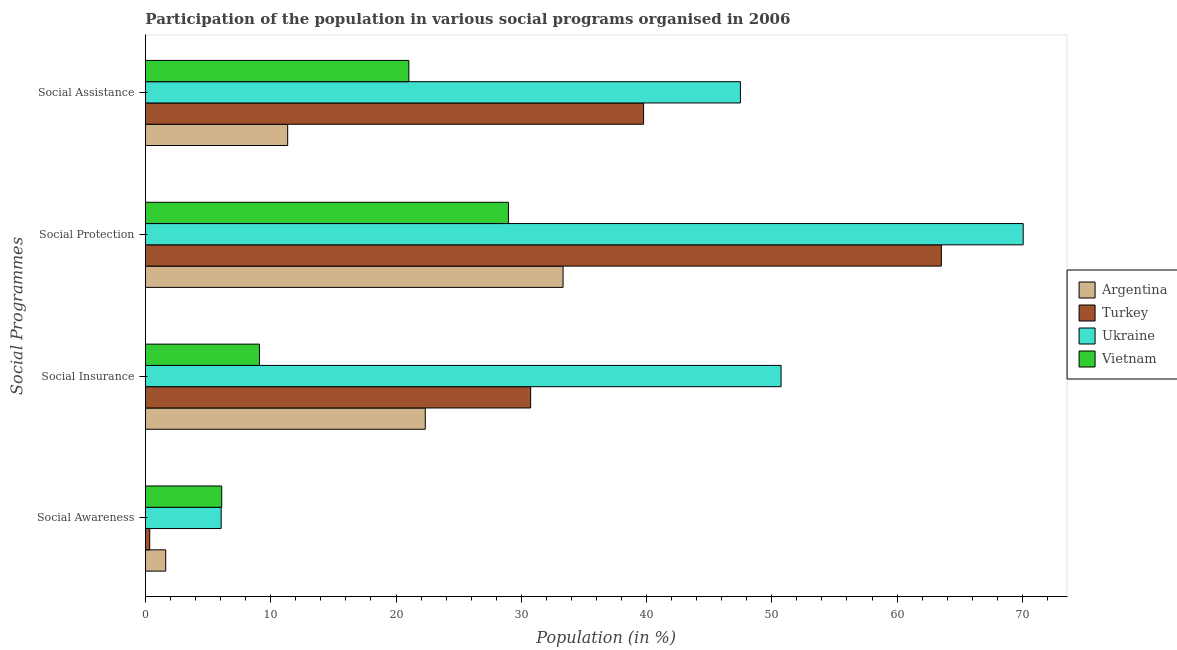How many different coloured bars are there?
Offer a very short reply. 4. How many groups of bars are there?
Ensure brevity in your answer.  4. Are the number of bars per tick equal to the number of legend labels?
Your response must be concise. Yes. How many bars are there on the 1st tick from the top?
Provide a short and direct response. 4. What is the label of the 3rd group of bars from the top?
Ensure brevity in your answer.  Social Insurance. What is the participation of population in social assistance programs in Ukraine?
Keep it short and to the point. 47.5. Across all countries, what is the maximum participation of population in social assistance programs?
Offer a very short reply. 47.5. Across all countries, what is the minimum participation of population in social assistance programs?
Make the answer very short. 11.35. In which country was the participation of population in social protection programs maximum?
Give a very brief answer. Ukraine. What is the total participation of population in social protection programs in the graph?
Your answer should be compact. 195.91. What is the difference between the participation of population in social protection programs in Ukraine and that in Vietnam?
Provide a short and direct response. 41.09. What is the difference between the participation of population in social assistance programs in Argentina and the participation of population in social awareness programs in Ukraine?
Your response must be concise. 5.31. What is the average participation of population in social awareness programs per country?
Provide a succinct answer. 3.52. What is the difference between the participation of population in social protection programs and participation of population in social insurance programs in Vietnam?
Your answer should be very brief. 19.88. In how many countries, is the participation of population in social awareness programs greater than 56 %?
Give a very brief answer. 0. What is the ratio of the participation of population in social assistance programs in Ukraine to that in Vietnam?
Make the answer very short. 2.26. Is the difference between the participation of population in social protection programs in Turkey and Argentina greater than the difference between the participation of population in social awareness programs in Turkey and Argentina?
Offer a terse response. Yes. What is the difference between the highest and the second highest participation of population in social insurance programs?
Your answer should be very brief. 19.99. What is the difference between the highest and the lowest participation of population in social protection programs?
Your response must be concise. 41.09. In how many countries, is the participation of population in social assistance programs greater than the average participation of population in social assistance programs taken over all countries?
Your answer should be compact. 2. Is the sum of the participation of population in social assistance programs in Turkey and Argentina greater than the maximum participation of population in social insurance programs across all countries?
Offer a terse response. Yes. What does the 2nd bar from the top in Social Protection represents?
Your answer should be very brief. Ukraine. What does the 3rd bar from the bottom in Social Insurance represents?
Your answer should be compact. Ukraine. Is it the case that in every country, the sum of the participation of population in social awareness programs and participation of population in social insurance programs is greater than the participation of population in social protection programs?
Give a very brief answer. No. How many bars are there?
Offer a terse response. 16. What is the difference between two consecutive major ticks on the X-axis?
Provide a succinct answer. 10. Does the graph contain any zero values?
Keep it short and to the point. No. Does the graph contain grids?
Offer a terse response. No. Where does the legend appear in the graph?
Give a very brief answer. Center right. How are the legend labels stacked?
Give a very brief answer. Vertical. What is the title of the graph?
Provide a short and direct response. Participation of the population in various social programs organised in 2006. Does "Antigua and Barbuda" appear as one of the legend labels in the graph?
Keep it short and to the point. No. What is the label or title of the X-axis?
Give a very brief answer. Population (in %). What is the label or title of the Y-axis?
Your answer should be compact. Social Programmes. What is the Population (in %) of Argentina in Social Awareness?
Your response must be concise. 1.62. What is the Population (in %) of Turkey in Social Awareness?
Provide a succinct answer. 0.34. What is the Population (in %) of Ukraine in Social Awareness?
Your answer should be very brief. 6.04. What is the Population (in %) in Vietnam in Social Awareness?
Your response must be concise. 6.09. What is the Population (in %) in Argentina in Social Insurance?
Your answer should be very brief. 22.34. What is the Population (in %) in Turkey in Social Insurance?
Provide a succinct answer. 30.75. What is the Population (in %) in Ukraine in Social Insurance?
Make the answer very short. 50.74. What is the Population (in %) in Vietnam in Social Insurance?
Offer a very short reply. 9.1. What is the Population (in %) of Argentina in Social Protection?
Provide a short and direct response. 33.34. What is the Population (in %) of Turkey in Social Protection?
Keep it short and to the point. 63.53. What is the Population (in %) of Ukraine in Social Protection?
Provide a succinct answer. 70.07. What is the Population (in %) of Vietnam in Social Protection?
Provide a succinct answer. 28.98. What is the Population (in %) in Argentina in Social Assistance?
Ensure brevity in your answer.  11.35. What is the Population (in %) of Turkey in Social Assistance?
Your response must be concise. 39.76. What is the Population (in %) of Ukraine in Social Assistance?
Keep it short and to the point. 47.5. What is the Population (in %) in Vietnam in Social Assistance?
Give a very brief answer. 21.03. Across all Social Programmes, what is the maximum Population (in %) of Argentina?
Keep it short and to the point. 33.34. Across all Social Programmes, what is the maximum Population (in %) of Turkey?
Offer a very short reply. 63.53. Across all Social Programmes, what is the maximum Population (in %) in Ukraine?
Make the answer very short. 70.07. Across all Social Programmes, what is the maximum Population (in %) of Vietnam?
Keep it short and to the point. 28.98. Across all Social Programmes, what is the minimum Population (in %) in Argentina?
Your answer should be very brief. 1.62. Across all Social Programmes, what is the minimum Population (in %) in Turkey?
Offer a terse response. 0.34. Across all Social Programmes, what is the minimum Population (in %) of Ukraine?
Ensure brevity in your answer.  6.04. Across all Social Programmes, what is the minimum Population (in %) of Vietnam?
Offer a very short reply. 6.09. What is the total Population (in %) of Argentina in the graph?
Your answer should be very brief. 68.64. What is the total Population (in %) of Turkey in the graph?
Give a very brief answer. 134.39. What is the total Population (in %) in Ukraine in the graph?
Offer a very short reply. 174.35. What is the total Population (in %) in Vietnam in the graph?
Your answer should be very brief. 65.19. What is the difference between the Population (in %) of Argentina in Social Awareness and that in Social Insurance?
Ensure brevity in your answer.  -20.72. What is the difference between the Population (in %) in Turkey in Social Awareness and that in Social Insurance?
Ensure brevity in your answer.  -30.41. What is the difference between the Population (in %) in Ukraine in Social Awareness and that in Social Insurance?
Provide a short and direct response. -44.7. What is the difference between the Population (in %) of Vietnam in Social Awareness and that in Social Insurance?
Keep it short and to the point. -3.01. What is the difference between the Population (in %) of Argentina in Social Awareness and that in Social Protection?
Provide a short and direct response. -31.72. What is the difference between the Population (in %) of Turkey in Social Awareness and that in Social Protection?
Your answer should be very brief. -63.19. What is the difference between the Population (in %) in Ukraine in Social Awareness and that in Social Protection?
Keep it short and to the point. -64.02. What is the difference between the Population (in %) in Vietnam in Social Awareness and that in Social Protection?
Ensure brevity in your answer.  -22.89. What is the difference between the Population (in %) in Argentina in Social Awareness and that in Social Assistance?
Your answer should be very brief. -9.74. What is the difference between the Population (in %) of Turkey in Social Awareness and that in Social Assistance?
Provide a short and direct response. -39.42. What is the difference between the Population (in %) of Ukraine in Social Awareness and that in Social Assistance?
Ensure brevity in your answer.  -41.45. What is the difference between the Population (in %) in Vietnam in Social Awareness and that in Social Assistance?
Provide a short and direct response. -14.94. What is the difference between the Population (in %) of Argentina in Social Insurance and that in Social Protection?
Your answer should be very brief. -11. What is the difference between the Population (in %) of Turkey in Social Insurance and that in Social Protection?
Your answer should be compact. -32.78. What is the difference between the Population (in %) of Ukraine in Social Insurance and that in Social Protection?
Your answer should be very brief. -19.33. What is the difference between the Population (in %) of Vietnam in Social Insurance and that in Social Protection?
Your answer should be compact. -19.88. What is the difference between the Population (in %) of Argentina in Social Insurance and that in Social Assistance?
Provide a succinct answer. 10.98. What is the difference between the Population (in %) of Turkey in Social Insurance and that in Social Assistance?
Your response must be concise. -9.01. What is the difference between the Population (in %) of Ukraine in Social Insurance and that in Social Assistance?
Your answer should be compact. 3.24. What is the difference between the Population (in %) in Vietnam in Social Insurance and that in Social Assistance?
Provide a succinct answer. -11.93. What is the difference between the Population (in %) in Argentina in Social Protection and that in Social Assistance?
Your answer should be very brief. 21.98. What is the difference between the Population (in %) of Turkey in Social Protection and that in Social Assistance?
Offer a terse response. 23.77. What is the difference between the Population (in %) in Ukraine in Social Protection and that in Social Assistance?
Your answer should be very brief. 22.57. What is the difference between the Population (in %) of Vietnam in Social Protection and that in Social Assistance?
Offer a very short reply. 7.95. What is the difference between the Population (in %) of Argentina in Social Awareness and the Population (in %) of Turkey in Social Insurance?
Your answer should be very brief. -29.13. What is the difference between the Population (in %) in Argentina in Social Awareness and the Population (in %) in Ukraine in Social Insurance?
Your answer should be very brief. -49.12. What is the difference between the Population (in %) of Argentina in Social Awareness and the Population (in %) of Vietnam in Social Insurance?
Your answer should be compact. -7.48. What is the difference between the Population (in %) in Turkey in Social Awareness and the Population (in %) in Ukraine in Social Insurance?
Give a very brief answer. -50.4. What is the difference between the Population (in %) in Turkey in Social Awareness and the Population (in %) in Vietnam in Social Insurance?
Offer a very short reply. -8.76. What is the difference between the Population (in %) of Ukraine in Social Awareness and the Population (in %) of Vietnam in Social Insurance?
Provide a succinct answer. -3.06. What is the difference between the Population (in %) of Argentina in Social Awareness and the Population (in %) of Turkey in Social Protection?
Provide a succinct answer. -61.92. What is the difference between the Population (in %) of Argentina in Social Awareness and the Population (in %) of Ukraine in Social Protection?
Provide a short and direct response. -68.45. What is the difference between the Population (in %) in Argentina in Social Awareness and the Population (in %) in Vietnam in Social Protection?
Your answer should be compact. -27.36. What is the difference between the Population (in %) in Turkey in Social Awareness and the Population (in %) in Ukraine in Social Protection?
Keep it short and to the point. -69.73. What is the difference between the Population (in %) of Turkey in Social Awareness and the Population (in %) of Vietnam in Social Protection?
Keep it short and to the point. -28.64. What is the difference between the Population (in %) in Ukraine in Social Awareness and the Population (in %) in Vietnam in Social Protection?
Keep it short and to the point. -22.93. What is the difference between the Population (in %) in Argentina in Social Awareness and the Population (in %) in Turkey in Social Assistance?
Provide a succinct answer. -38.15. What is the difference between the Population (in %) in Argentina in Social Awareness and the Population (in %) in Ukraine in Social Assistance?
Provide a short and direct response. -45.88. What is the difference between the Population (in %) of Argentina in Social Awareness and the Population (in %) of Vietnam in Social Assistance?
Offer a terse response. -19.41. What is the difference between the Population (in %) of Turkey in Social Awareness and the Population (in %) of Ukraine in Social Assistance?
Ensure brevity in your answer.  -47.15. What is the difference between the Population (in %) in Turkey in Social Awareness and the Population (in %) in Vietnam in Social Assistance?
Your response must be concise. -20.69. What is the difference between the Population (in %) of Ukraine in Social Awareness and the Population (in %) of Vietnam in Social Assistance?
Offer a terse response. -14.98. What is the difference between the Population (in %) in Argentina in Social Insurance and the Population (in %) in Turkey in Social Protection?
Offer a very short reply. -41.2. What is the difference between the Population (in %) in Argentina in Social Insurance and the Population (in %) in Ukraine in Social Protection?
Your answer should be compact. -47.73. What is the difference between the Population (in %) of Argentina in Social Insurance and the Population (in %) of Vietnam in Social Protection?
Offer a very short reply. -6.64. What is the difference between the Population (in %) of Turkey in Social Insurance and the Population (in %) of Ukraine in Social Protection?
Keep it short and to the point. -39.32. What is the difference between the Population (in %) in Turkey in Social Insurance and the Population (in %) in Vietnam in Social Protection?
Provide a succinct answer. 1.77. What is the difference between the Population (in %) in Ukraine in Social Insurance and the Population (in %) in Vietnam in Social Protection?
Keep it short and to the point. 21.76. What is the difference between the Population (in %) of Argentina in Social Insurance and the Population (in %) of Turkey in Social Assistance?
Your response must be concise. -17.43. What is the difference between the Population (in %) of Argentina in Social Insurance and the Population (in %) of Ukraine in Social Assistance?
Your answer should be very brief. -25.16. What is the difference between the Population (in %) in Argentina in Social Insurance and the Population (in %) in Vietnam in Social Assistance?
Your response must be concise. 1.31. What is the difference between the Population (in %) in Turkey in Social Insurance and the Population (in %) in Ukraine in Social Assistance?
Offer a very short reply. -16.75. What is the difference between the Population (in %) in Turkey in Social Insurance and the Population (in %) in Vietnam in Social Assistance?
Your answer should be compact. 9.72. What is the difference between the Population (in %) of Ukraine in Social Insurance and the Population (in %) of Vietnam in Social Assistance?
Offer a very short reply. 29.71. What is the difference between the Population (in %) in Argentina in Social Protection and the Population (in %) in Turkey in Social Assistance?
Your answer should be compact. -6.43. What is the difference between the Population (in %) in Argentina in Social Protection and the Population (in %) in Ukraine in Social Assistance?
Provide a succinct answer. -14.16. What is the difference between the Population (in %) in Argentina in Social Protection and the Population (in %) in Vietnam in Social Assistance?
Your answer should be very brief. 12.31. What is the difference between the Population (in %) in Turkey in Social Protection and the Population (in %) in Ukraine in Social Assistance?
Ensure brevity in your answer.  16.04. What is the difference between the Population (in %) of Turkey in Social Protection and the Population (in %) of Vietnam in Social Assistance?
Give a very brief answer. 42.51. What is the difference between the Population (in %) in Ukraine in Social Protection and the Population (in %) in Vietnam in Social Assistance?
Provide a succinct answer. 49.04. What is the average Population (in %) in Argentina per Social Programmes?
Provide a succinct answer. 17.16. What is the average Population (in %) in Turkey per Social Programmes?
Offer a terse response. 33.6. What is the average Population (in %) in Ukraine per Social Programmes?
Your answer should be compact. 43.59. What is the average Population (in %) of Vietnam per Social Programmes?
Provide a short and direct response. 16.3. What is the difference between the Population (in %) of Argentina and Population (in %) of Turkey in Social Awareness?
Your response must be concise. 1.28. What is the difference between the Population (in %) in Argentina and Population (in %) in Ukraine in Social Awareness?
Make the answer very short. -4.43. What is the difference between the Population (in %) in Argentina and Population (in %) in Vietnam in Social Awareness?
Offer a terse response. -4.47. What is the difference between the Population (in %) of Turkey and Population (in %) of Ukraine in Social Awareness?
Provide a succinct answer. -5.7. What is the difference between the Population (in %) of Turkey and Population (in %) of Vietnam in Social Awareness?
Your response must be concise. -5.75. What is the difference between the Population (in %) in Ukraine and Population (in %) in Vietnam in Social Awareness?
Ensure brevity in your answer.  -0.04. What is the difference between the Population (in %) of Argentina and Population (in %) of Turkey in Social Insurance?
Your answer should be compact. -8.41. What is the difference between the Population (in %) of Argentina and Population (in %) of Ukraine in Social Insurance?
Offer a terse response. -28.4. What is the difference between the Population (in %) in Argentina and Population (in %) in Vietnam in Social Insurance?
Ensure brevity in your answer.  13.24. What is the difference between the Population (in %) of Turkey and Population (in %) of Ukraine in Social Insurance?
Offer a very short reply. -19.99. What is the difference between the Population (in %) in Turkey and Population (in %) in Vietnam in Social Insurance?
Keep it short and to the point. 21.65. What is the difference between the Population (in %) of Ukraine and Population (in %) of Vietnam in Social Insurance?
Offer a very short reply. 41.64. What is the difference between the Population (in %) in Argentina and Population (in %) in Turkey in Social Protection?
Provide a short and direct response. -30.2. What is the difference between the Population (in %) in Argentina and Population (in %) in Ukraine in Social Protection?
Give a very brief answer. -36.73. What is the difference between the Population (in %) of Argentina and Population (in %) of Vietnam in Social Protection?
Your response must be concise. 4.36. What is the difference between the Population (in %) of Turkey and Population (in %) of Ukraine in Social Protection?
Offer a very short reply. -6.53. What is the difference between the Population (in %) in Turkey and Population (in %) in Vietnam in Social Protection?
Provide a short and direct response. 34.56. What is the difference between the Population (in %) in Ukraine and Population (in %) in Vietnam in Social Protection?
Offer a very short reply. 41.09. What is the difference between the Population (in %) in Argentina and Population (in %) in Turkey in Social Assistance?
Offer a terse response. -28.41. What is the difference between the Population (in %) of Argentina and Population (in %) of Ukraine in Social Assistance?
Your answer should be very brief. -36.14. What is the difference between the Population (in %) of Argentina and Population (in %) of Vietnam in Social Assistance?
Your answer should be compact. -9.67. What is the difference between the Population (in %) in Turkey and Population (in %) in Ukraine in Social Assistance?
Your answer should be very brief. -7.73. What is the difference between the Population (in %) of Turkey and Population (in %) of Vietnam in Social Assistance?
Offer a very short reply. 18.74. What is the difference between the Population (in %) of Ukraine and Population (in %) of Vietnam in Social Assistance?
Offer a terse response. 26.47. What is the ratio of the Population (in %) in Argentina in Social Awareness to that in Social Insurance?
Keep it short and to the point. 0.07. What is the ratio of the Population (in %) in Turkey in Social Awareness to that in Social Insurance?
Give a very brief answer. 0.01. What is the ratio of the Population (in %) of Ukraine in Social Awareness to that in Social Insurance?
Your answer should be very brief. 0.12. What is the ratio of the Population (in %) in Vietnam in Social Awareness to that in Social Insurance?
Offer a very short reply. 0.67. What is the ratio of the Population (in %) in Argentina in Social Awareness to that in Social Protection?
Your response must be concise. 0.05. What is the ratio of the Population (in %) of Turkey in Social Awareness to that in Social Protection?
Make the answer very short. 0.01. What is the ratio of the Population (in %) in Ukraine in Social Awareness to that in Social Protection?
Provide a short and direct response. 0.09. What is the ratio of the Population (in %) of Vietnam in Social Awareness to that in Social Protection?
Offer a terse response. 0.21. What is the ratio of the Population (in %) in Argentina in Social Awareness to that in Social Assistance?
Your answer should be very brief. 0.14. What is the ratio of the Population (in %) of Turkey in Social Awareness to that in Social Assistance?
Your answer should be very brief. 0.01. What is the ratio of the Population (in %) in Ukraine in Social Awareness to that in Social Assistance?
Your answer should be compact. 0.13. What is the ratio of the Population (in %) in Vietnam in Social Awareness to that in Social Assistance?
Make the answer very short. 0.29. What is the ratio of the Population (in %) in Argentina in Social Insurance to that in Social Protection?
Your answer should be compact. 0.67. What is the ratio of the Population (in %) of Turkey in Social Insurance to that in Social Protection?
Offer a very short reply. 0.48. What is the ratio of the Population (in %) of Ukraine in Social Insurance to that in Social Protection?
Provide a succinct answer. 0.72. What is the ratio of the Population (in %) in Vietnam in Social Insurance to that in Social Protection?
Provide a short and direct response. 0.31. What is the ratio of the Population (in %) of Argentina in Social Insurance to that in Social Assistance?
Offer a very short reply. 1.97. What is the ratio of the Population (in %) of Turkey in Social Insurance to that in Social Assistance?
Your answer should be very brief. 0.77. What is the ratio of the Population (in %) of Ukraine in Social Insurance to that in Social Assistance?
Provide a short and direct response. 1.07. What is the ratio of the Population (in %) of Vietnam in Social Insurance to that in Social Assistance?
Your answer should be very brief. 0.43. What is the ratio of the Population (in %) in Argentina in Social Protection to that in Social Assistance?
Keep it short and to the point. 2.94. What is the ratio of the Population (in %) of Turkey in Social Protection to that in Social Assistance?
Make the answer very short. 1.6. What is the ratio of the Population (in %) of Ukraine in Social Protection to that in Social Assistance?
Make the answer very short. 1.48. What is the ratio of the Population (in %) in Vietnam in Social Protection to that in Social Assistance?
Ensure brevity in your answer.  1.38. What is the difference between the highest and the second highest Population (in %) of Argentina?
Provide a succinct answer. 11. What is the difference between the highest and the second highest Population (in %) of Turkey?
Ensure brevity in your answer.  23.77. What is the difference between the highest and the second highest Population (in %) in Ukraine?
Your answer should be compact. 19.33. What is the difference between the highest and the second highest Population (in %) of Vietnam?
Offer a terse response. 7.95. What is the difference between the highest and the lowest Population (in %) in Argentina?
Keep it short and to the point. 31.72. What is the difference between the highest and the lowest Population (in %) of Turkey?
Offer a terse response. 63.19. What is the difference between the highest and the lowest Population (in %) in Ukraine?
Provide a succinct answer. 64.02. What is the difference between the highest and the lowest Population (in %) of Vietnam?
Ensure brevity in your answer.  22.89. 